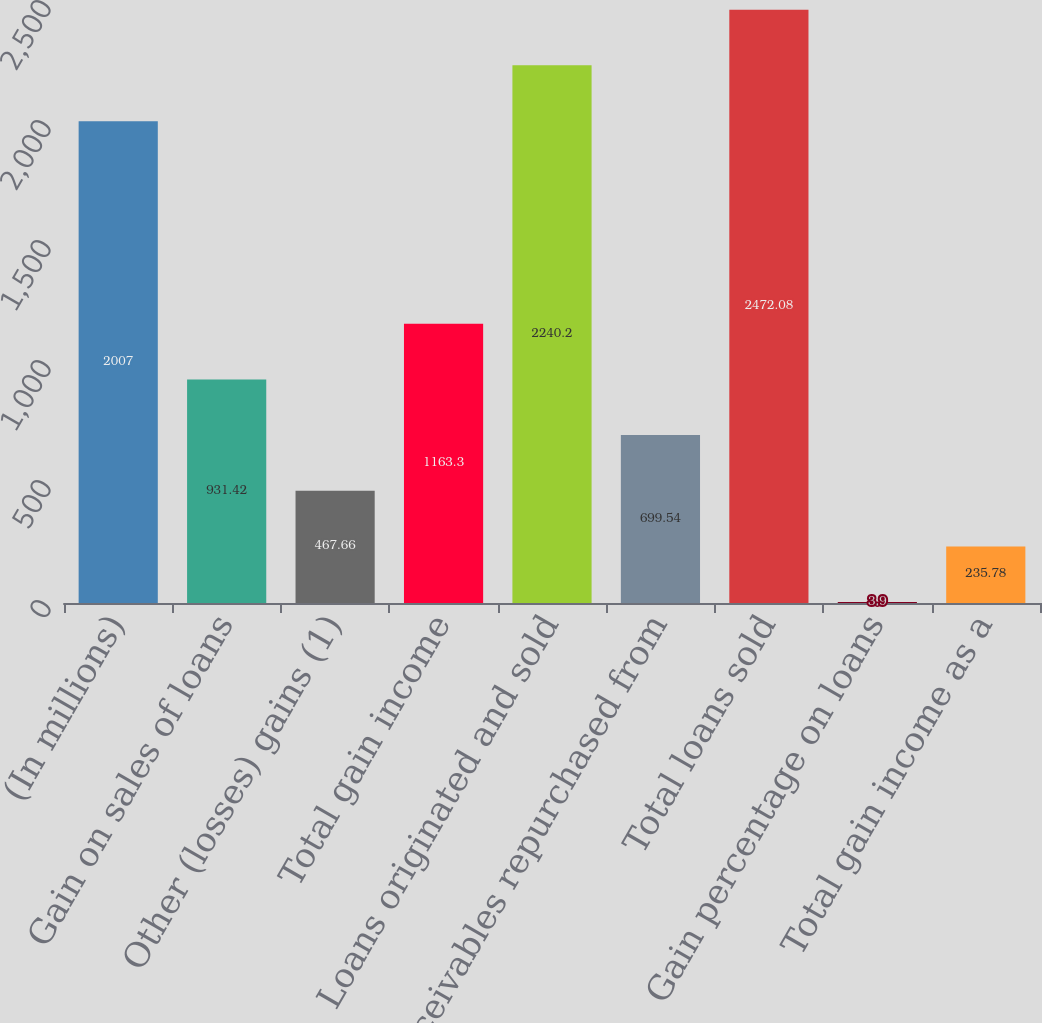Convert chart. <chart><loc_0><loc_0><loc_500><loc_500><bar_chart><fcel>(In millions)<fcel>Gain on sales of loans<fcel>Other (losses) gains (1)<fcel>Total gain income<fcel>Loans originated and sold<fcel>Receivables repurchased from<fcel>Total loans sold<fcel>Gain percentage on loans<fcel>Total gain income as a<nl><fcel>2007<fcel>931.42<fcel>467.66<fcel>1163.3<fcel>2240.2<fcel>699.54<fcel>2472.08<fcel>3.9<fcel>235.78<nl></chart> 